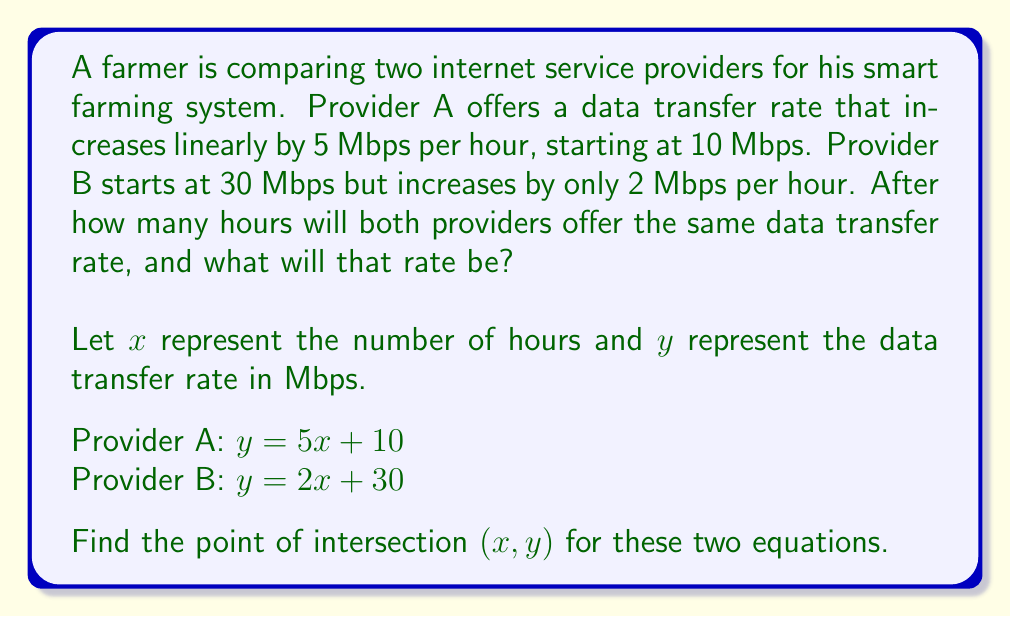Give your solution to this math problem. To find the point of intersection, we need to solve the system of equations:

$$\begin{cases}
y = 5x + 10 \\
y = 2x + 30
\end{cases}$$

Step 1: Set the equations equal to each other since they intersect at the same point.
$5x + 10 = 2x + 30$

Step 2: Subtract $2x$ from both sides.
$3x + 10 = 30$

Step 3: Subtract 10 from both sides.
$3x = 20$

Step 4: Divide both sides by 3.
$x = \frac{20}{3} \approx 6.67$ hours

Step 5: Substitute this x-value into either equation to find y. Let's use Provider A's equation:
$y = 5(\frac{20}{3}) + 10 = \frac{100}{3} + 10 = \frac{130}{3} \approx 43.33$ Mbps

Therefore, the point of intersection is $(\frac{20}{3}, \frac{130}{3})$ or approximately (6.67, 43.33).
Answer: $(\frac{20}{3}, \frac{130}{3})$ hours, Mbps 